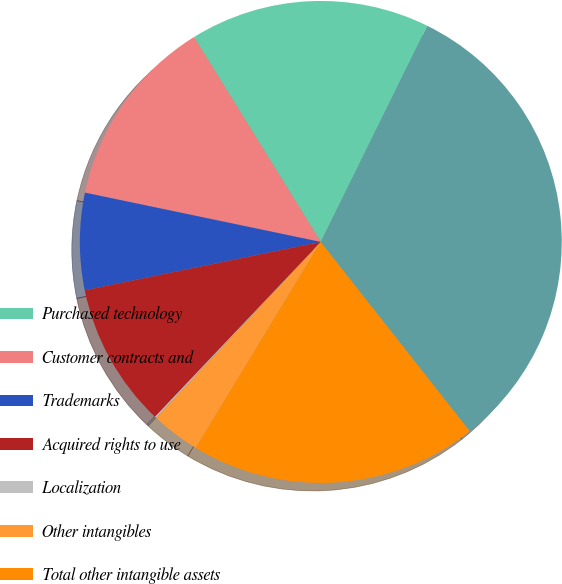Convert chart. <chart><loc_0><loc_0><loc_500><loc_500><pie_chart><fcel>Purchased technology<fcel>Customer contracts and<fcel>Trademarks<fcel>Acquired rights to use<fcel>Localization<fcel>Other intangibles<fcel>Total other intangible assets<fcel>Purchased and other intangible<nl><fcel>16.1%<fcel>12.9%<fcel>6.5%<fcel>9.7%<fcel>0.1%<fcel>3.3%<fcel>19.3%<fcel>32.09%<nl></chart> 